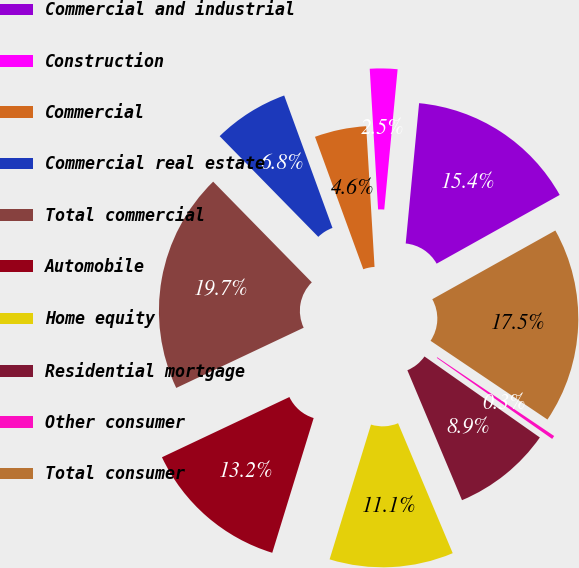Convert chart to OTSL. <chart><loc_0><loc_0><loc_500><loc_500><pie_chart><fcel>Commercial and industrial<fcel>Construction<fcel>Commercial<fcel>Commercial real estate<fcel>Total commercial<fcel>Automobile<fcel>Home equity<fcel>Residential mortgage<fcel>Other consumer<fcel>Total consumer<nl><fcel>15.38%<fcel>2.46%<fcel>4.62%<fcel>6.77%<fcel>19.69%<fcel>13.23%<fcel>11.08%<fcel>8.92%<fcel>0.31%<fcel>17.54%<nl></chart> 